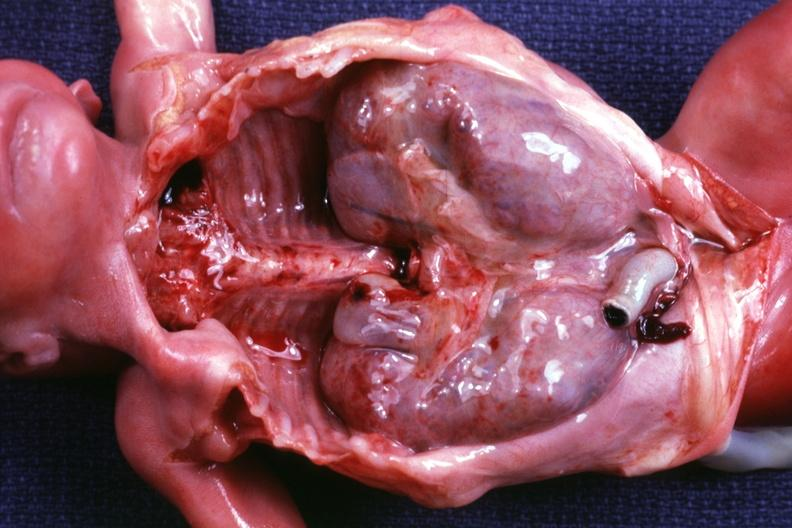s polycystic disease infant present?
Answer the question using a single word or phrase. Yes 